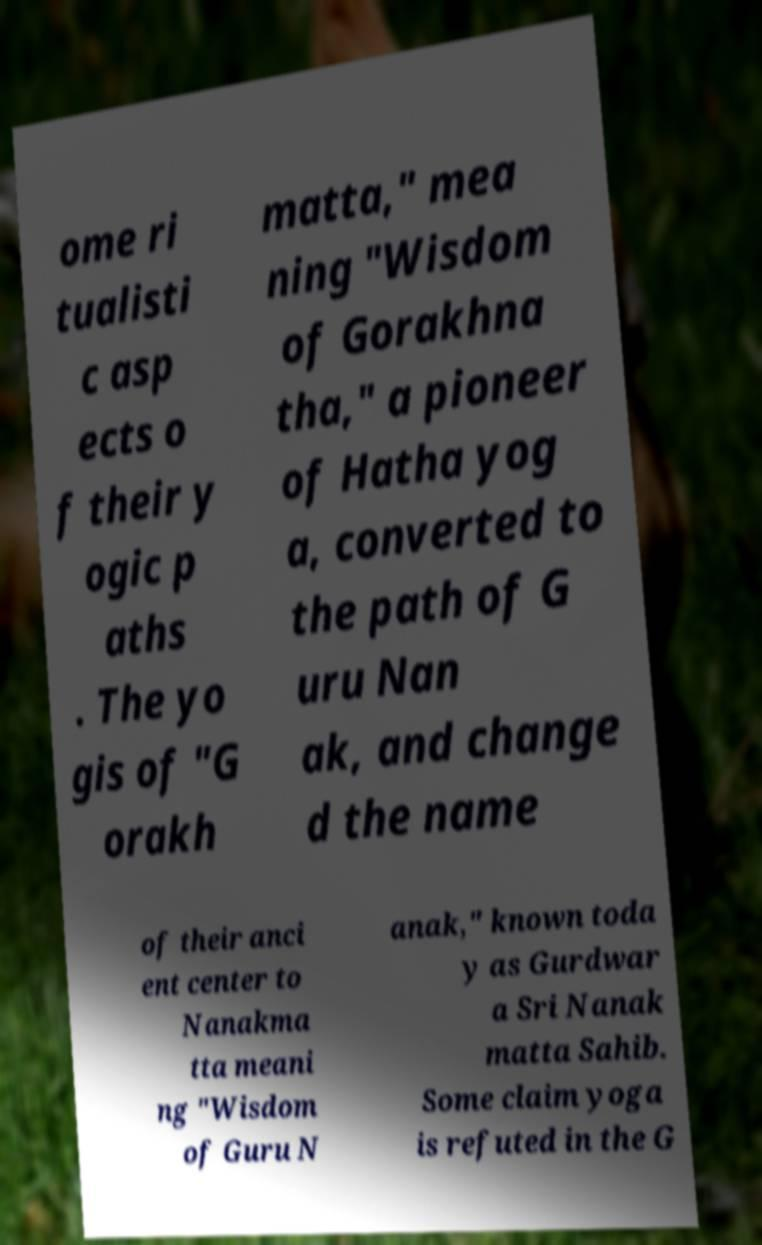Could you extract and type out the text from this image? ome ri tualisti c asp ects o f their y ogic p aths . The yo gis of "G orakh matta," mea ning "Wisdom of Gorakhna tha," a pioneer of Hatha yog a, converted to the path of G uru Nan ak, and change d the name of their anci ent center to Nanakma tta meani ng "Wisdom of Guru N anak," known toda y as Gurdwar a Sri Nanak matta Sahib. Some claim yoga is refuted in the G 